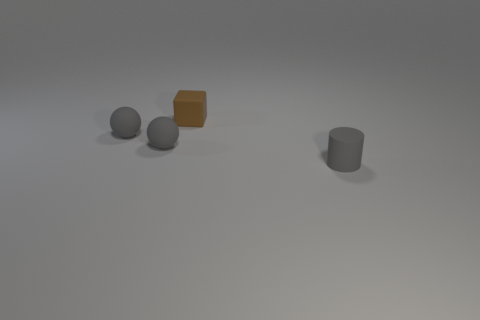There is a brown rubber object that is the same size as the gray matte cylinder; what shape is it?
Keep it short and to the point. Cube. What number of things are small brown blocks or small matte things that are left of the block?
Your answer should be very brief. 3. What color is the block that is made of the same material as the cylinder?
Give a very brief answer. Brown. There is a rubber object that is to the right of the brown block; does it have the same size as the brown matte object?
Make the answer very short. Yes. How many objects are either small matte spheres or tiny blocks?
Offer a very short reply. 3. Are there any rubber spheres of the same size as the brown matte object?
Keep it short and to the point. Yes. How many cyan things are tiny matte cylinders or rubber cubes?
Keep it short and to the point. 0. What number of things are the same color as the tiny matte cylinder?
Provide a short and direct response. 2. Are the gray cylinder and the cube made of the same material?
Your answer should be very brief. Yes. There is a rubber thing to the right of the tiny brown rubber cube; what number of brown things are left of it?
Your answer should be very brief. 1. 